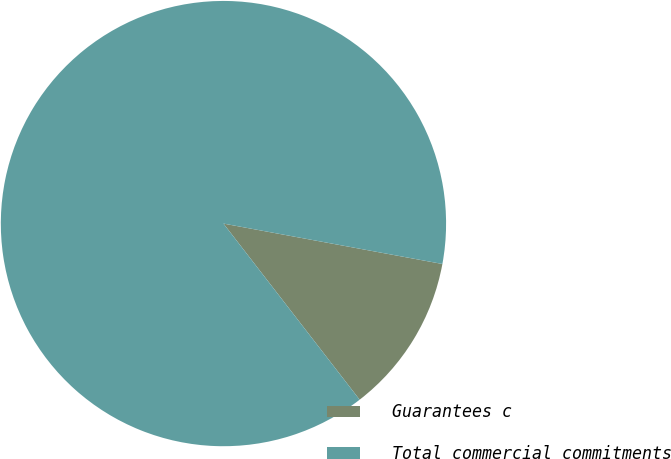Convert chart. <chart><loc_0><loc_0><loc_500><loc_500><pie_chart><fcel>Guarantees c<fcel>Total commercial commitments<nl><fcel>11.62%<fcel>88.38%<nl></chart> 